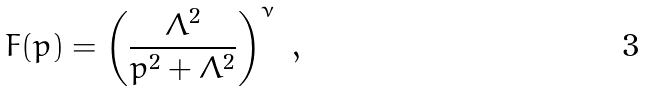Convert formula to latex. <formula><loc_0><loc_0><loc_500><loc_500>F ( p ) = \left ( { \frac { \Lambda ^ { 2 } } { p ^ { 2 } + \Lambda ^ { 2 } } } \right ) ^ { \nu } \ ,</formula> 